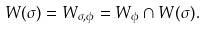Convert formula to latex. <formula><loc_0><loc_0><loc_500><loc_500>W ( \sigma ) = W _ { \sigma , \phi } = W _ { \phi } \cap W ( \sigma ) .</formula> 